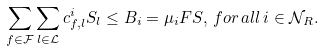<formula> <loc_0><loc_0><loc_500><loc_500>\sum _ { f \in \mathcal { F } } \sum _ { l \in \mathcal { L } } c _ { f , l } ^ { i } S _ { l } \leq B _ { i } = \mu _ { i } F S , \, f o r \, a l l \, i \in \mathcal { N } _ { R } .</formula> 